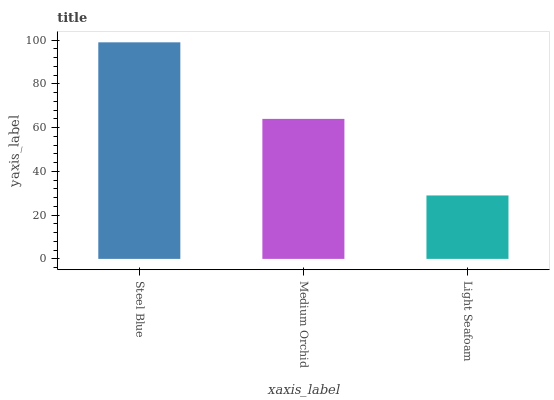Is Light Seafoam the minimum?
Answer yes or no. Yes. Is Steel Blue the maximum?
Answer yes or no. Yes. Is Medium Orchid the minimum?
Answer yes or no. No. Is Medium Orchid the maximum?
Answer yes or no. No. Is Steel Blue greater than Medium Orchid?
Answer yes or no. Yes. Is Medium Orchid less than Steel Blue?
Answer yes or no. Yes. Is Medium Orchid greater than Steel Blue?
Answer yes or no. No. Is Steel Blue less than Medium Orchid?
Answer yes or no. No. Is Medium Orchid the high median?
Answer yes or no. Yes. Is Medium Orchid the low median?
Answer yes or no. Yes. Is Steel Blue the high median?
Answer yes or no. No. Is Light Seafoam the low median?
Answer yes or no. No. 